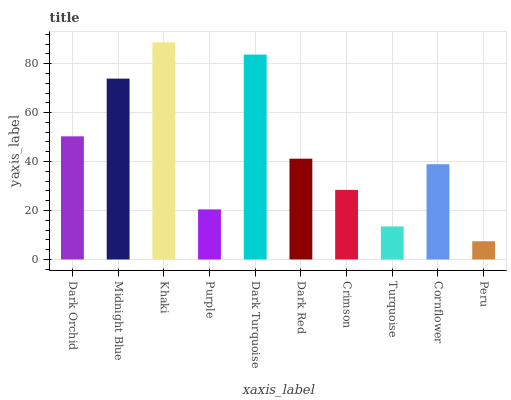Is Peru the minimum?
Answer yes or no. Yes. Is Khaki the maximum?
Answer yes or no. Yes. Is Midnight Blue the minimum?
Answer yes or no. No. Is Midnight Blue the maximum?
Answer yes or no. No. Is Midnight Blue greater than Dark Orchid?
Answer yes or no. Yes. Is Dark Orchid less than Midnight Blue?
Answer yes or no. Yes. Is Dark Orchid greater than Midnight Blue?
Answer yes or no. No. Is Midnight Blue less than Dark Orchid?
Answer yes or no. No. Is Dark Red the high median?
Answer yes or no. Yes. Is Cornflower the low median?
Answer yes or no. Yes. Is Turquoise the high median?
Answer yes or no. No. Is Turquoise the low median?
Answer yes or no. No. 